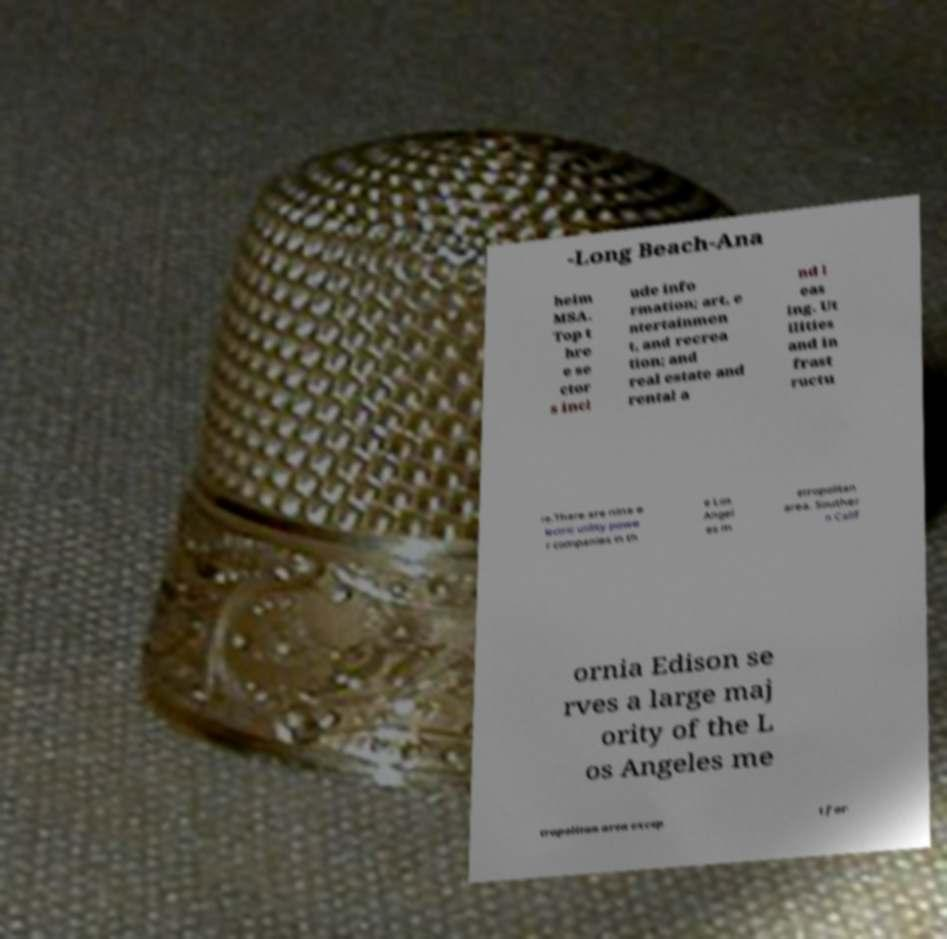For documentation purposes, I need the text within this image transcribed. Could you provide that? -Long Beach-Ana heim MSA. Top t hre e se ctor s incl ude info rmation; art, e ntertainmen t, and recrea tion; and real estate and rental a nd l eas ing. Ut ilities and in frast ructu re.There are nine e lectric utility powe r companies in th e Los Angel es m etropolitan area. Souther n Calif ornia Edison se rves a large maj ority of the L os Angeles me tropolitan area excep t for 